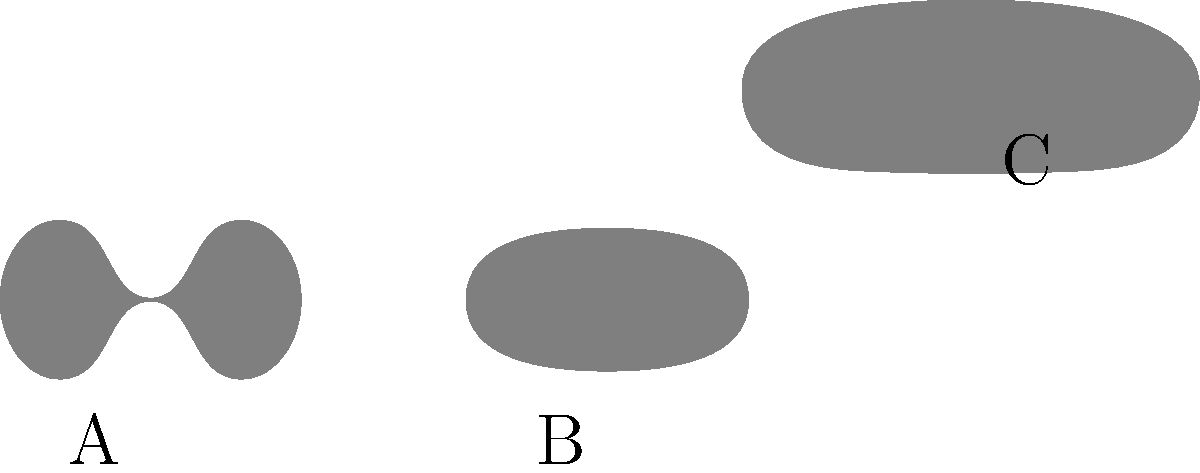As a marine mammal veterinarian, you are presented with silhouettes of three different marine mammals. Which silhouette (A, B, or C) most likely represents a seal? To identify the seal silhouette, let's analyze each shape:

1. Silhouette A:
   - Elongated body with a distinct dorsal fin
   - Streamlined shape with a long snout
   - Characteristic of a dolphin

2. Silhouette B:
   - Rounded, torpedo-shaped body
   - No visible dorsal fin or flippers
   - Smooth outline typical of a seal's body shape when resting

3. Silhouette C:
   - Large, elongated body
   - Distinctive tail flukes
   - Small dorsal fin positioned towards the rear
   - Characteristic of a whale

Based on these observations, silhouette B most closely resembles a seal's body shape. Seals have a streamlined, fusiform body that appears rounded when they are at rest on land or ice. They lack a prominent dorsal fin, which distinguishes them from dolphins and whales.
Answer: B 